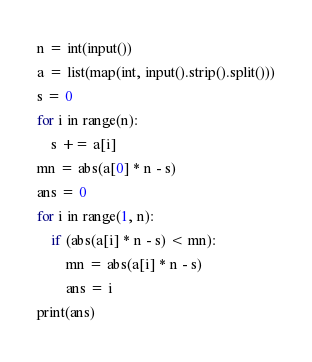<code> <loc_0><loc_0><loc_500><loc_500><_Python_>n = int(input())
a = list(map(int, input().strip().split()))
s = 0
for i in range(n):
	s += a[i]
mn = abs(a[0] * n - s)
ans = 0
for i in range(1, n):
	if (abs(a[i] * n - s) < mn):
		mn = abs(a[i] * n - s)
		ans = i
print(ans)
</code> 